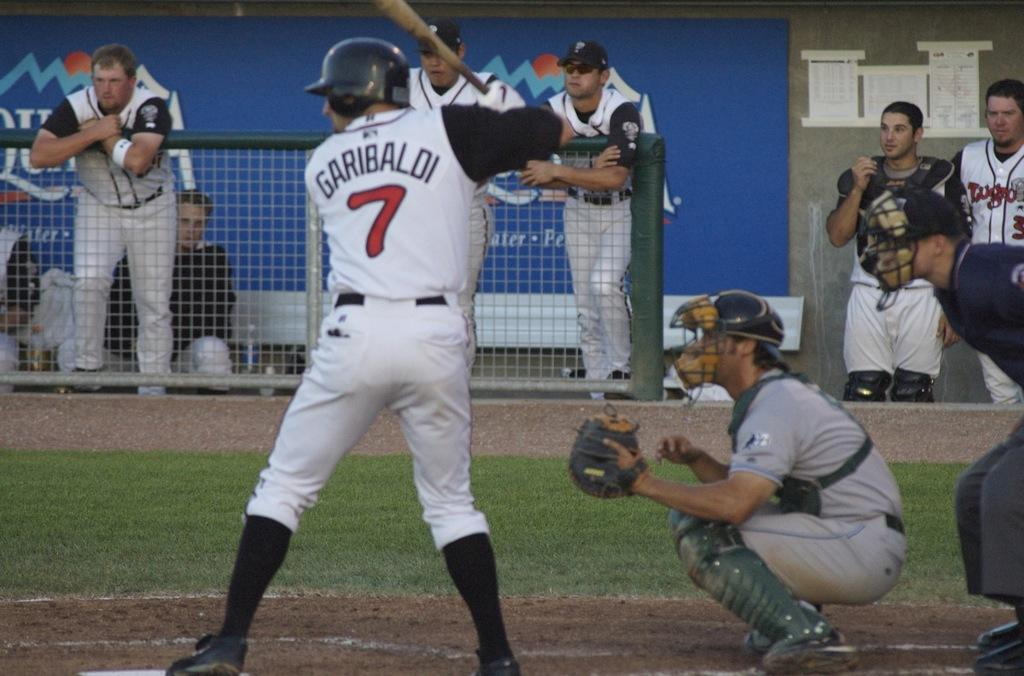Provide a one-sentence caption for the provided image. A batter in a white jersey named Garibaldi with the number 7. 